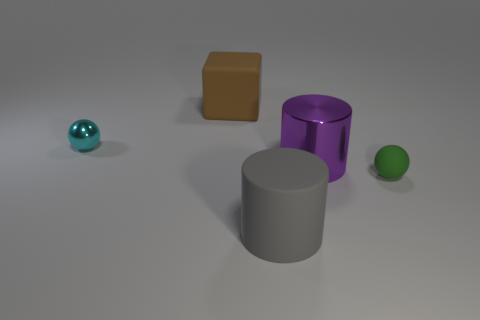There is a green ball; does it have the same size as the rubber thing behind the tiny green sphere?
Your response must be concise. No. There is a small ball to the right of the rubber block; what is it made of?
Your response must be concise. Rubber. Is the number of small things that are in front of the large rubber cylinder the same as the number of large brown things?
Provide a succinct answer. No. Do the gray matte object and the green thing have the same size?
Keep it short and to the point. No. There is a matte sphere in front of the small ball left of the large brown matte block; is there a brown rubber object in front of it?
Your answer should be very brief. No. There is a small cyan thing that is the same shape as the small green matte thing; what is it made of?
Provide a succinct answer. Metal. There is a metallic object that is behind the purple object; how many large brown matte objects are in front of it?
Your response must be concise. 0. There is a object behind the small thing on the left side of the cylinder that is in front of the large purple metallic object; how big is it?
Your answer should be compact. Large. The big rubber thing that is behind the large rubber thing in front of the big brown cube is what color?
Make the answer very short. Brown. What number of other things are there of the same material as the purple cylinder
Give a very brief answer. 1. 